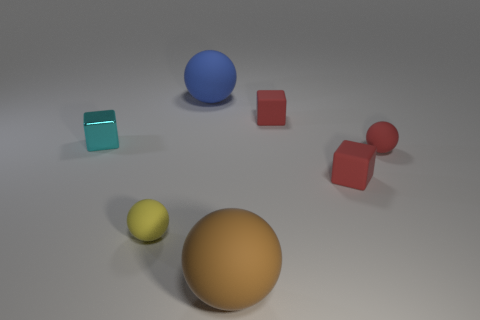Subtract all yellow balls. How many balls are left? 3 Subtract all yellow cylinders. How many red blocks are left? 2 Add 2 large balls. How many objects exist? 9 Subtract all yellow spheres. How many spheres are left? 3 Subtract 1 spheres. How many spheres are left? 3 Add 5 shiny blocks. How many shiny blocks are left? 6 Add 4 rubber blocks. How many rubber blocks exist? 6 Subtract 0 gray cylinders. How many objects are left? 7 Subtract all cubes. How many objects are left? 4 Subtract all brown spheres. Subtract all green cubes. How many spheres are left? 3 